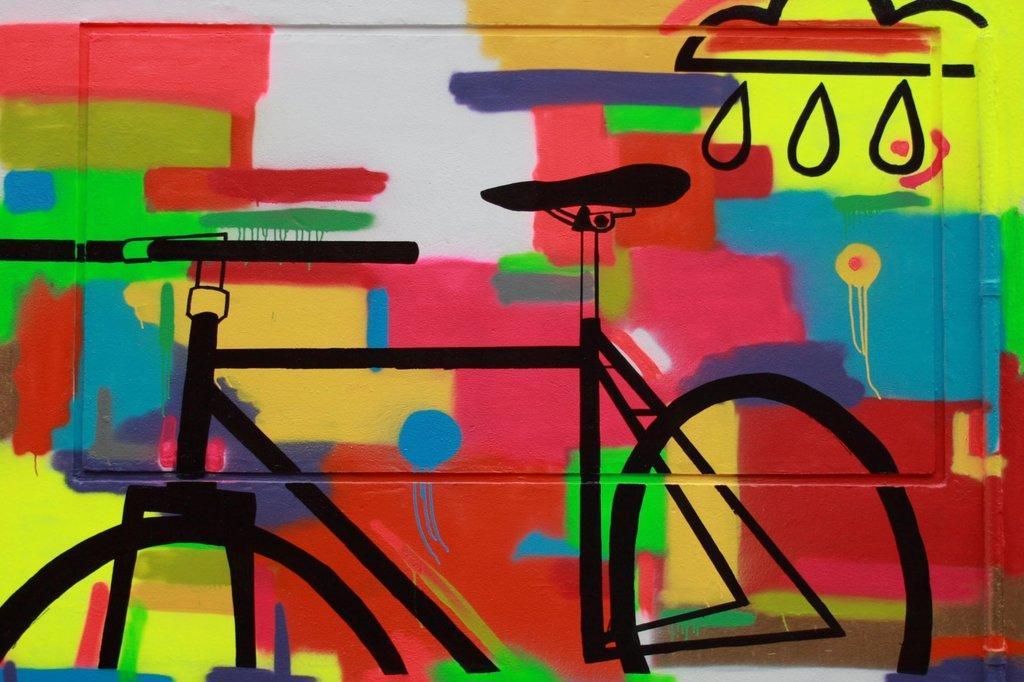Please provide a concise description of this image. In the picture we can see painting on the wall which is in the shape of bicycle. 